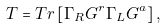Convert formula to latex. <formula><loc_0><loc_0><loc_500><loc_500>T = T r \left [ \Gamma _ { R } G ^ { r } \Gamma _ { L } G ^ { a } \right ] ,</formula> 